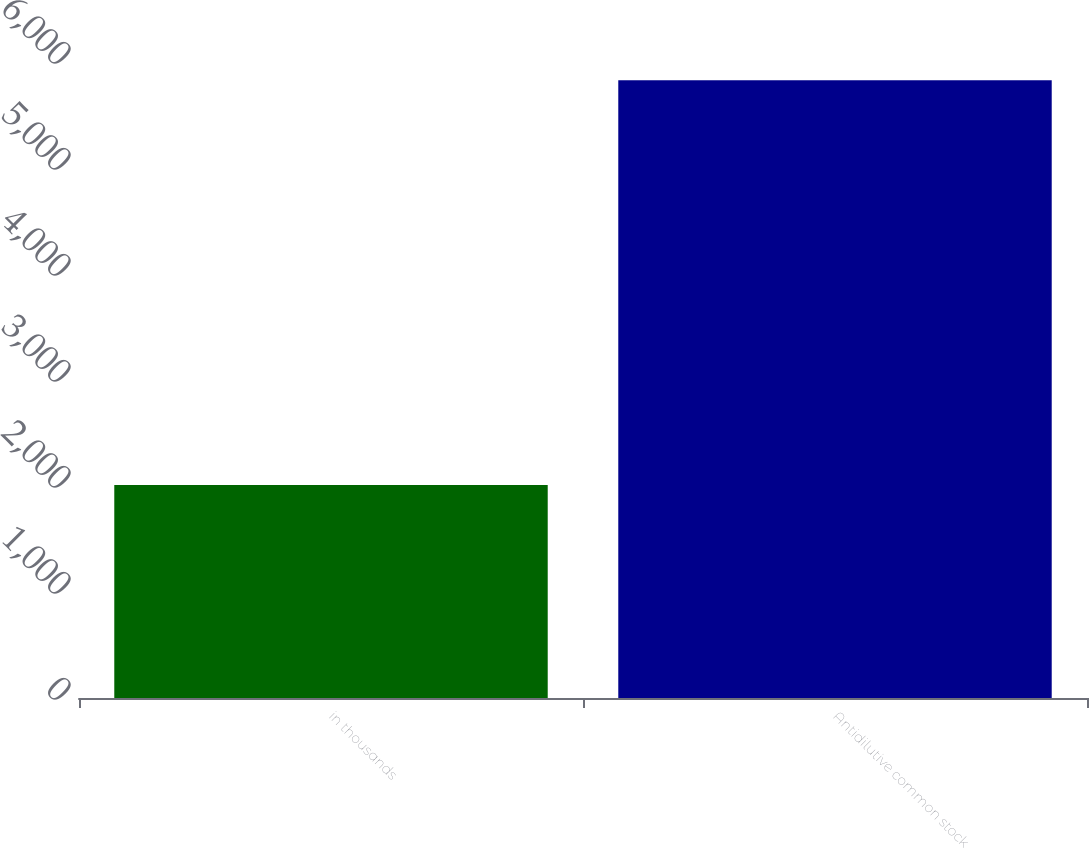<chart> <loc_0><loc_0><loc_500><loc_500><bar_chart><fcel>in thousands<fcel>Antidilutive common stock<nl><fcel>2010<fcel>5827<nl></chart> 